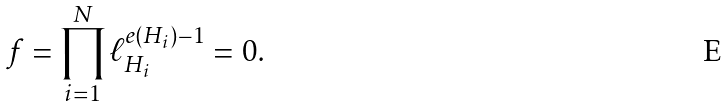Convert formula to latex. <formula><loc_0><loc_0><loc_500><loc_500>f = \prod _ { i = 1 } ^ { N } \ell _ { H _ { i } } ^ { e ( H _ { i } ) - 1 } = 0 .</formula> 